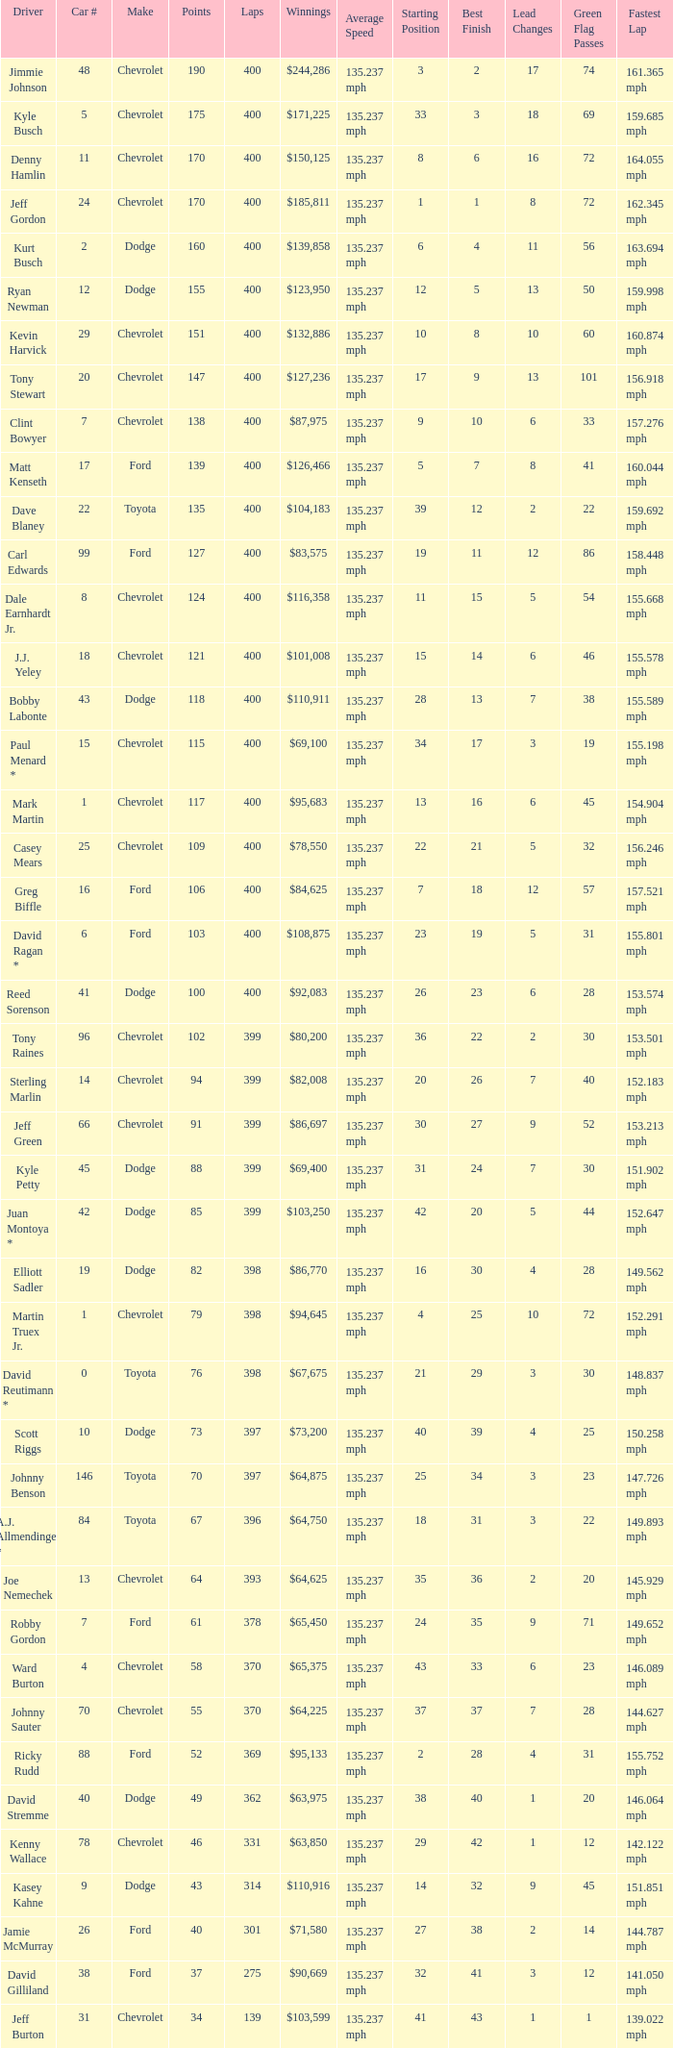What were the winnings for the Chevrolet with a number larger than 29 and scored 102 points? $80,200. 